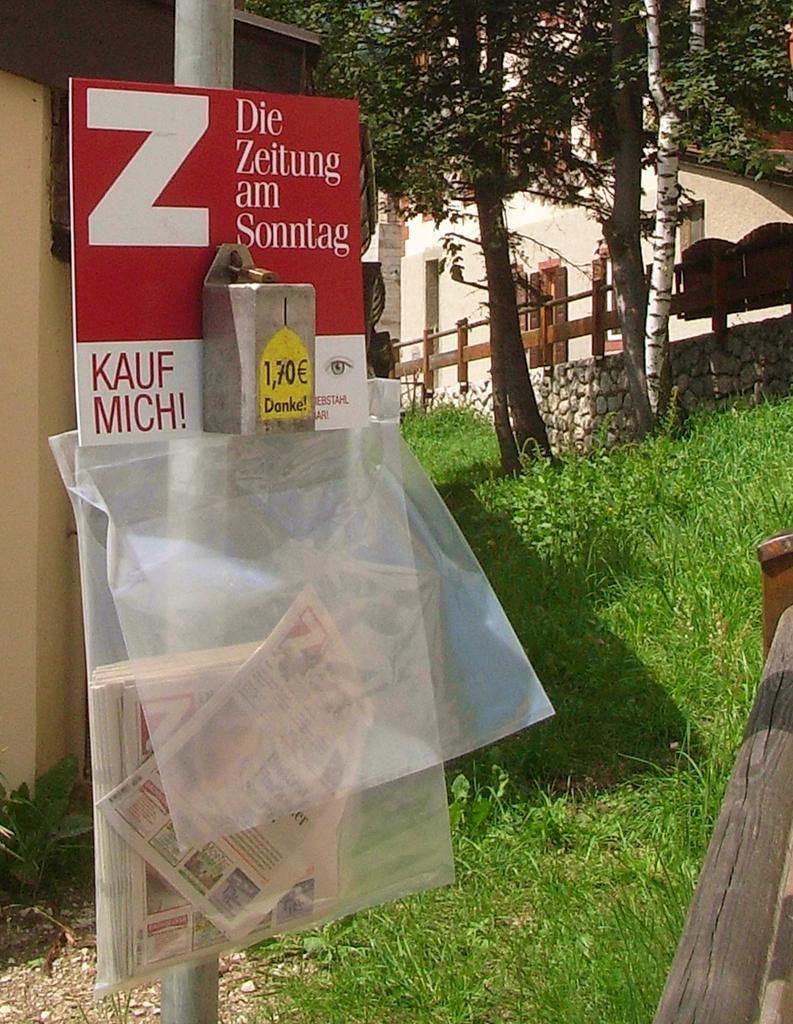How would you summarize this image in a sentence or two? In this picture, we can see a pole with poster, and some text on it, we can see some object attached to it, and transparent covers and some papers in it, we can see the ground with grass, we can see wooden object in the bottom right side of the picture, fencing, wall, buildings, and trees in the background. 